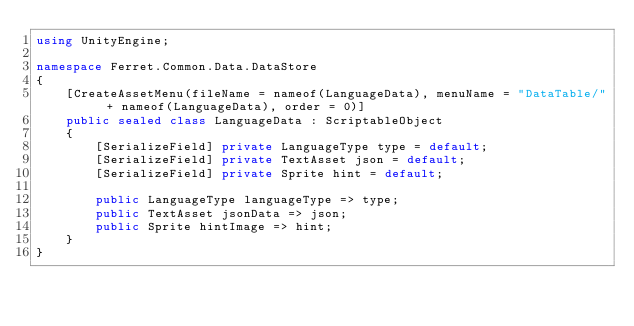Convert code to text. <code><loc_0><loc_0><loc_500><loc_500><_C#_>using UnityEngine;

namespace Ferret.Common.Data.DataStore
{
    [CreateAssetMenu(fileName = nameof(LanguageData), menuName = "DataTable/" + nameof(LanguageData), order = 0)]
    public sealed class LanguageData : ScriptableObject
    {
        [SerializeField] private LanguageType type = default;
        [SerializeField] private TextAsset json = default;
        [SerializeField] private Sprite hint = default;

        public LanguageType languageType => type;
        public TextAsset jsonData => json;
        public Sprite hintImage => hint;
    }
}</code> 